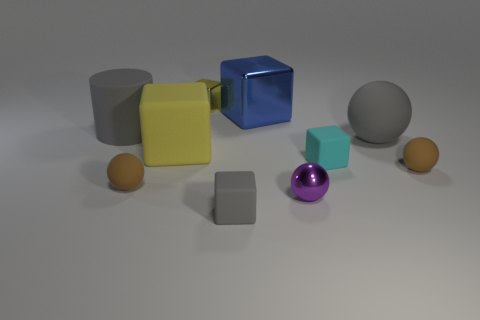Can you tell me which shapes in the picture have the same color? The two spheres share the same sandy brown color, while the large purple sphere and the medium-sized rubber cylinder have the same hue of vibrant purple. 